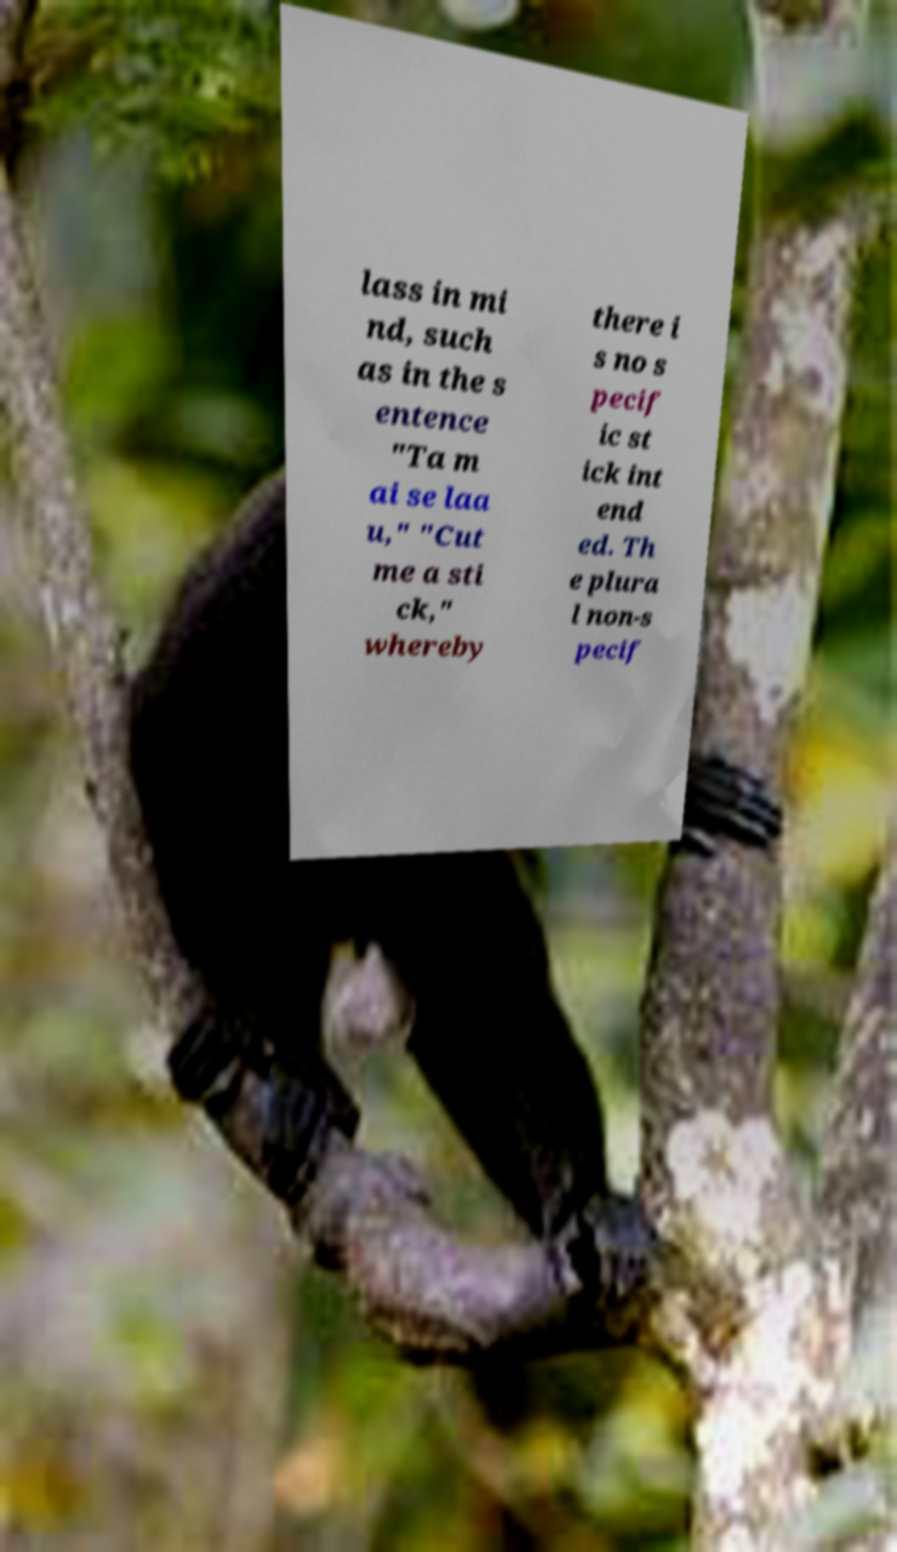Can you accurately transcribe the text from the provided image for me? lass in mi nd, such as in the s entence "Ta m ai se laa u," "Cut me a sti ck," whereby there i s no s pecif ic st ick int end ed. Th e plura l non-s pecif 